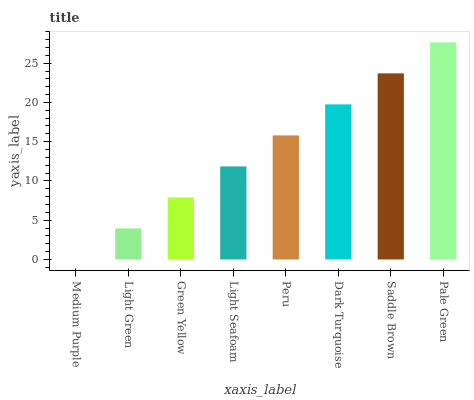Is Medium Purple the minimum?
Answer yes or no. Yes. Is Pale Green the maximum?
Answer yes or no. Yes. Is Light Green the minimum?
Answer yes or no. No. Is Light Green the maximum?
Answer yes or no. No. Is Light Green greater than Medium Purple?
Answer yes or no. Yes. Is Medium Purple less than Light Green?
Answer yes or no. Yes. Is Medium Purple greater than Light Green?
Answer yes or no. No. Is Light Green less than Medium Purple?
Answer yes or no. No. Is Peru the high median?
Answer yes or no. Yes. Is Light Seafoam the low median?
Answer yes or no. Yes. Is Medium Purple the high median?
Answer yes or no. No. Is Pale Green the low median?
Answer yes or no. No. 